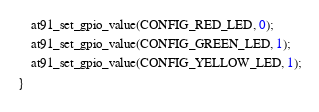<code> <loc_0><loc_0><loc_500><loc_500><_C_>
	at91_set_gpio_value(CONFIG_RED_LED, 0);
	at91_set_gpio_value(CONFIG_GREEN_LED, 1);
	at91_set_gpio_value(CONFIG_YELLOW_LED, 1);
}
</code> 